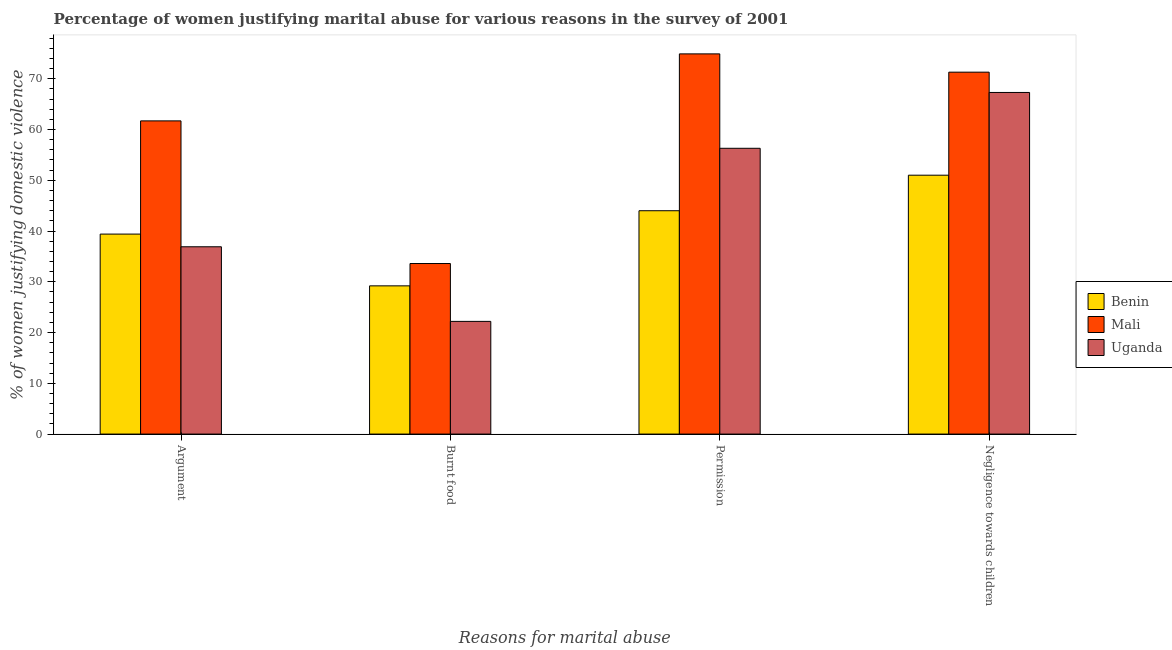How many different coloured bars are there?
Offer a very short reply. 3. Are the number of bars per tick equal to the number of legend labels?
Provide a short and direct response. Yes. How many bars are there on the 2nd tick from the left?
Offer a terse response. 3. What is the label of the 4th group of bars from the left?
Your answer should be compact. Negligence towards children. What is the percentage of women justifying abuse for going without permission in Benin?
Your answer should be very brief. 44. Across all countries, what is the maximum percentage of women justifying abuse for burning food?
Give a very brief answer. 33.6. In which country was the percentage of women justifying abuse for burning food maximum?
Provide a short and direct response. Mali. In which country was the percentage of women justifying abuse for going without permission minimum?
Offer a terse response. Benin. What is the total percentage of women justifying abuse for showing negligence towards children in the graph?
Ensure brevity in your answer.  189.6. What is the difference between the percentage of women justifying abuse for going without permission in Uganda and that in Mali?
Your answer should be compact. -18.6. What is the difference between the percentage of women justifying abuse for showing negligence towards children in Benin and the percentage of women justifying abuse in the case of an argument in Mali?
Offer a very short reply. -10.7. What is the average percentage of women justifying abuse for going without permission per country?
Your response must be concise. 58.4. What is the difference between the percentage of women justifying abuse for showing negligence towards children and percentage of women justifying abuse in the case of an argument in Mali?
Your response must be concise. 9.6. In how many countries, is the percentage of women justifying abuse for burning food greater than 16 %?
Your answer should be compact. 3. What is the ratio of the percentage of women justifying abuse for burning food in Mali to that in Uganda?
Keep it short and to the point. 1.51. Is the difference between the percentage of women justifying abuse for going without permission in Mali and Uganda greater than the difference between the percentage of women justifying abuse for showing negligence towards children in Mali and Uganda?
Your response must be concise. Yes. What is the difference between the highest and the second highest percentage of women justifying abuse in the case of an argument?
Offer a terse response. 22.3. What is the difference between the highest and the lowest percentage of women justifying abuse for showing negligence towards children?
Give a very brief answer. 20.3. In how many countries, is the percentage of women justifying abuse in the case of an argument greater than the average percentage of women justifying abuse in the case of an argument taken over all countries?
Provide a short and direct response. 1. Is it the case that in every country, the sum of the percentage of women justifying abuse for going without permission and percentage of women justifying abuse for showing negligence towards children is greater than the sum of percentage of women justifying abuse in the case of an argument and percentage of women justifying abuse for burning food?
Offer a terse response. No. What does the 3rd bar from the left in Argument represents?
Your answer should be compact. Uganda. What does the 3rd bar from the right in Permission represents?
Provide a short and direct response. Benin. Is it the case that in every country, the sum of the percentage of women justifying abuse in the case of an argument and percentage of women justifying abuse for burning food is greater than the percentage of women justifying abuse for going without permission?
Provide a succinct answer. Yes. How many bars are there?
Provide a short and direct response. 12. How many countries are there in the graph?
Offer a very short reply. 3. What is the difference between two consecutive major ticks on the Y-axis?
Give a very brief answer. 10. Does the graph contain any zero values?
Provide a succinct answer. No. Does the graph contain grids?
Your answer should be compact. No. Where does the legend appear in the graph?
Provide a short and direct response. Center right. How many legend labels are there?
Your response must be concise. 3. How are the legend labels stacked?
Make the answer very short. Vertical. What is the title of the graph?
Offer a terse response. Percentage of women justifying marital abuse for various reasons in the survey of 2001. What is the label or title of the X-axis?
Your answer should be compact. Reasons for marital abuse. What is the label or title of the Y-axis?
Offer a very short reply. % of women justifying domestic violence. What is the % of women justifying domestic violence in Benin in Argument?
Provide a succinct answer. 39.4. What is the % of women justifying domestic violence of Mali in Argument?
Make the answer very short. 61.7. What is the % of women justifying domestic violence in Uganda in Argument?
Give a very brief answer. 36.9. What is the % of women justifying domestic violence in Benin in Burnt food?
Provide a short and direct response. 29.2. What is the % of women justifying domestic violence in Mali in Burnt food?
Your answer should be compact. 33.6. What is the % of women justifying domestic violence in Uganda in Burnt food?
Provide a succinct answer. 22.2. What is the % of women justifying domestic violence in Mali in Permission?
Provide a succinct answer. 74.9. What is the % of women justifying domestic violence of Uganda in Permission?
Your answer should be very brief. 56.3. What is the % of women justifying domestic violence of Benin in Negligence towards children?
Your answer should be compact. 51. What is the % of women justifying domestic violence in Mali in Negligence towards children?
Your response must be concise. 71.3. What is the % of women justifying domestic violence in Uganda in Negligence towards children?
Offer a very short reply. 67.3. Across all Reasons for marital abuse, what is the maximum % of women justifying domestic violence in Mali?
Offer a very short reply. 74.9. Across all Reasons for marital abuse, what is the maximum % of women justifying domestic violence of Uganda?
Provide a succinct answer. 67.3. Across all Reasons for marital abuse, what is the minimum % of women justifying domestic violence in Benin?
Make the answer very short. 29.2. Across all Reasons for marital abuse, what is the minimum % of women justifying domestic violence of Mali?
Keep it short and to the point. 33.6. Across all Reasons for marital abuse, what is the minimum % of women justifying domestic violence of Uganda?
Offer a very short reply. 22.2. What is the total % of women justifying domestic violence in Benin in the graph?
Offer a very short reply. 163.6. What is the total % of women justifying domestic violence in Mali in the graph?
Your answer should be compact. 241.5. What is the total % of women justifying domestic violence of Uganda in the graph?
Ensure brevity in your answer.  182.7. What is the difference between the % of women justifying domestic violence in Benin in Argument and that in Burnt food?
Provide a short and direct response. 10.2. What is the difference between the % of women justifying domestic violence in Mali in Argument and that in Burnt food?
Your answer should be compact. 28.1. What is the difference between the % of women justifying domestic violence of Benin in Argument and that in Permission?
Provide a succinct answer. -4.6. What is the difference between the % of women justifying domestic violence of Mali in Argument and that in Permission?
Provide a short and direct response. -13.2. What is the difference between the % of women justifying domestic violence in Uganda in Argument and that in Permission?
Keep it short and to the point. -19.4. What is the difference between the % of women justifying domestic violence of Benin in Argument and that in Negligence towards children?
Give a very brief answer. -11.6. What is the difference between the % of women justifying domestic violence in Uganda in Argument and that in Negligence towards children?
Provide a short and direct response. -30.4. What is the difference between the % of women justifying domestic violence of Benin in Burnt food and that in Permission?
Offer a terse response. -14.8. What is the difference between the % of women justifying domestic violence of Mali in Burnt food and that in Permission?
Make the answer very short. -41.3. What is the difference between the % of women justifying domestic violence of Uganda in Burnt food and that in Permission?
Offer a very short reply. -34.1. What is the difference between the % of women justifying domestic violence of Benin in Burnt food and that in Negligence towards children?
Your answer should be very brief. -21.8. What is the difference between the % of women justifying domestic violence of Mali in Burnt food and that in Negligence towards children?
Offer a terse response. -37.7. What is the difference between the % of women justifying domestic violence in Uganda in Burnt food and that in Negligence towards children?
Keep it short and to the point. -45.1. What is the difference between the % of women justifying domestic violence in Benin in Permission and that in Negligence towards children?
Your answer should be very brief. -7. What is the difference between the % of women justifying domestic violence of Mali in Permission and that in Negligence towards children?
Give a very brief answer. 3.6. What is the difference between the % of women justifying domestic violence of Uganda in Permission and that in Negligence towards children?
Give a very brief answer. -11. What is the difference between the % of women justifying domestic violence of Mali in Argument and the % of women justifying domestic violence of Uganda in Burnt food?
Make the answer very short. 39.5. What is the difference between the % of women justifying domestic violence of Benin in Argument and the % of women justifying domestic violence of Mali in Permission?
Offer a very short reply. -35.5. What is the difference between the % of women justifying domestic violence of Benin in Argument and the % of women justifying domestic violence of Uganda in Permission?
Keep it short and to the point. -16.9. What is the difference between the % of women justifying domestic violence in Mali in Argument and the % of women justifying domestic violence in Uganda in Permission?
Make the answer very short. 5.4. What is the difference between the % of women justifying domestic violence of Benin in Argument and the % of women justifying domestic violence of Mali in Negligence towards children?
Your answer should be compact. -31.9. What is the difference between the % of women justifying domestic violence in Benin in Argument and the % of women justifying domestic violence in Uganda in Negligence towards children?
Offer a terse response. -27.9. What is the difference between the % of women justifying domestic violence of Mali in Argument and the % of women justifying domestic violence of Uganda in Negligence towards children?
Ensure brevity in your answer.  -5.6. What is the difference between the % of women justifying domestic violence of Benin in Burnt food and the % of women justifying domestic violence of Mali in Permission?
Your response must be concise. -45.7. What is the difference between the % of women justifying domestic violence in Benin in Burnt food and the % of women justifying domestic violence in Uganda in Permission?
Offer a terse response. -27.1. What is the difference between the % of women justifying domestic violence of Mali in Burnt food and the % of women justifying domestic violence of Uganda in Permission?
Give a very brief answer. -22.7. What is the difference between the % of women justifying domestic violence of Benin in Burnt food and the % of women justifying domestic violence of Mali in Negligence towards children?
Keep it short and to the point. -42.1. What is the difference between the % of women justifying domestic violence of Benin in Burnt food and the % of women justifying domestic violence of Uganda in Negligence towards children?
Offer a very short reply. -38.1. What is the difference between the % of women justifying domestic violence in Mali in Burnt food and the % of women justifying domestic violence in Uganda in Negligence towards children?
Offer a terse response. -33.7. What is the difference between the % of women justifying domestic violence of Benin in Permission and the % of women justifying domestic violence of Mali in Negligence towards children?
Provide a succinct answer. -27.3. What is the difference between the % of women justifying domestic violence of Benin in Permission and the % of women justifying domestic violence of Uganda in Negligence towards children?
Keep it short and to the point. -23.3. What is the average % of women justifying domestic violence in Benin per Reasons for marital abuse?
Your response must be concise. 40.9. What is the average % of women justifying domestic violence of Mali per Reasons for marital abuse?
Provide a succinct answer. 60.38. What is the average % of women justifying domestic violence in Uganda per Reasons for marital abuse?
Your answer should be very brief. 45.67. What is the difference between the % of women justifying domestic violence in Benin and % of women justifying domestic violence in Mali in Argument?
Give a very brief answer. -22.3. What is the difference between the % of women justifying domestic violence in Benin and % of women justifying domestic violence in Uganda in Argument?
Your answer should be very brief. 2.5. What is the difference between the % of women justifying domestic violence in Mali and % of women justifying domestic violence in Uganda in Argument?
Keep it short and to the point. 24.8. What is the difference between the % of women justifying domestic violence in Benin and % of women justifying domestic violence in Mali in Burnt food?
Ensure brevity in your answer.  -4.4. What is the difference between the % of women justifying domestic violence in Benin and % of women justifying domestic violence in Uganda in Burnt food?
Your answer should be very brief. 7. What is the difference between the % of women justifying domestic violence in Mali and % of women justifying domestic violence in Uganda in Burnt food?
Give a very brief answer. 11.4. What is the difference between the % of women justifying domestic violence in Benin and % of women justifying domestic violence in Mali in Permission?
Keep it short and to the point. -30.9. What is the difference between the % of women justifying domestic violence in Mali and % of women justifying domestic violence in Uganda in Permission?
Keep it short and to the point. 18.6. What is the difference between the % of women justifying domestic violence of Benin and % of women justifying domestic violence of Mali in Negligence towards children?
Give a very brief answer. -20.3. What is the difference between the % of women justifying domestic violence in Benin and % of women justifying domestic violence in Uganda in Negligence towards children?
Ensure brevity in your answer.  -16.3. What is the difference between the % of women justifying domestic violence of Mali and % of women justifying domestic violence of Uganda in Negligence towards children?
Provide a succinct answer. 4. What is the ratio of the % of women justifying domestic violence in Benin in Argument to that in Burnt food?
Make the answer very short. 1.35. What is the ratio of the % of women justifying domestic violence of Mali in Argument to that in Burnt food?
Keep it short and to the point. 1.84. What is the ratio of the % of women justifying domestic violence of Uganda in Argument to that in Burnt food?
Give a very brief answer. 1.66. What is the ratio of the % of women justifying domestic violence in Benin in Argument to that in Permission?
Provide a succinct answer. 0.9. What is the ratio of the % of women justifying domestic violence of Mali in Argument to that in Permission?
Your response must be concise. 0.82. What is the ratio of the % of women justifying domestic violence of Uganda in Argument to that in Permission?
Give a very brief answer. 0.66. What is the ratio of the % of women justifying domestic violence in Benin in Argument to that in Negligence towards children?
Your answer should be compact. 0.77. What is the ratio of the % of women justifying domestic violence of Mali in Argument to that in Negligence towards children?
Give a very brief answer. 0.87. What is the ratio of the % of women justifying domestic violence of Uganda in Argument to that in Negligence towards children?
Make the answer very short. 0.55. What is the ratio of the % of women justifying domestic violence of Benin in Burnt food to that in Permission?
Provide a short and direct response. 0.66. What is the ratio of the % of women justifying domestic violence in Mali in Burnt food to that in Permission?
Keep it short and to the point. 0.45. What is the ratio of the % of women justifying domestic violence of Uganda in Burnt food to that in Permission?
Provide a succinct answer. 0.39. What is the ratio of the % of women justifying domestic violence in Benin in Burnt food to that in Negligence towards children?
Offer a terse response. 0.57. What is the ratio of the % of women justifying domestic violence of Mali in Burnt food to that in Negligence towards children?
Keep it short and to the point. 0.47. What is the ratio of the % of women justifying domestic violence of Uganda in Burnt food to that in Negligence towards children?
Offer a very short reply. 0.33. What is the ratio of the % of women justifying domestic violence of Benin in Permission to that in Negligence towards children?
Provide a short and direct response. 0.86. What is the ratio of the % of women justifying domestic violence in Mali in Permission to that in Negligence towards children?
Your answer should be very brief. 1.05. What is the ratio of the % of women justifying domestic violence of Uganda in Permission to that in Negligence towards children?
Keep it short and to the point. 0.84. What is the difference between the highest and the second highest % of women justifying domestic violence of Mali?
Give a very brief answer. 3.6. What is the difference between the highest and the second highest % of women justifying domestic violence of Uganda?
Offer a terse response. 11. What is the difference between the highest and the lowest % of women justifying domestic violence of Benin?
Your answer should be compact. 21.8. What is the difference between the highest and the lowest % of women justifying domestic violence of Mali?
Offer a terse response. 41.3. What is the difference between the highest and the lowest % of women justifying domestic violence of Uganda?
Your answer should be very brief. 45.1. 